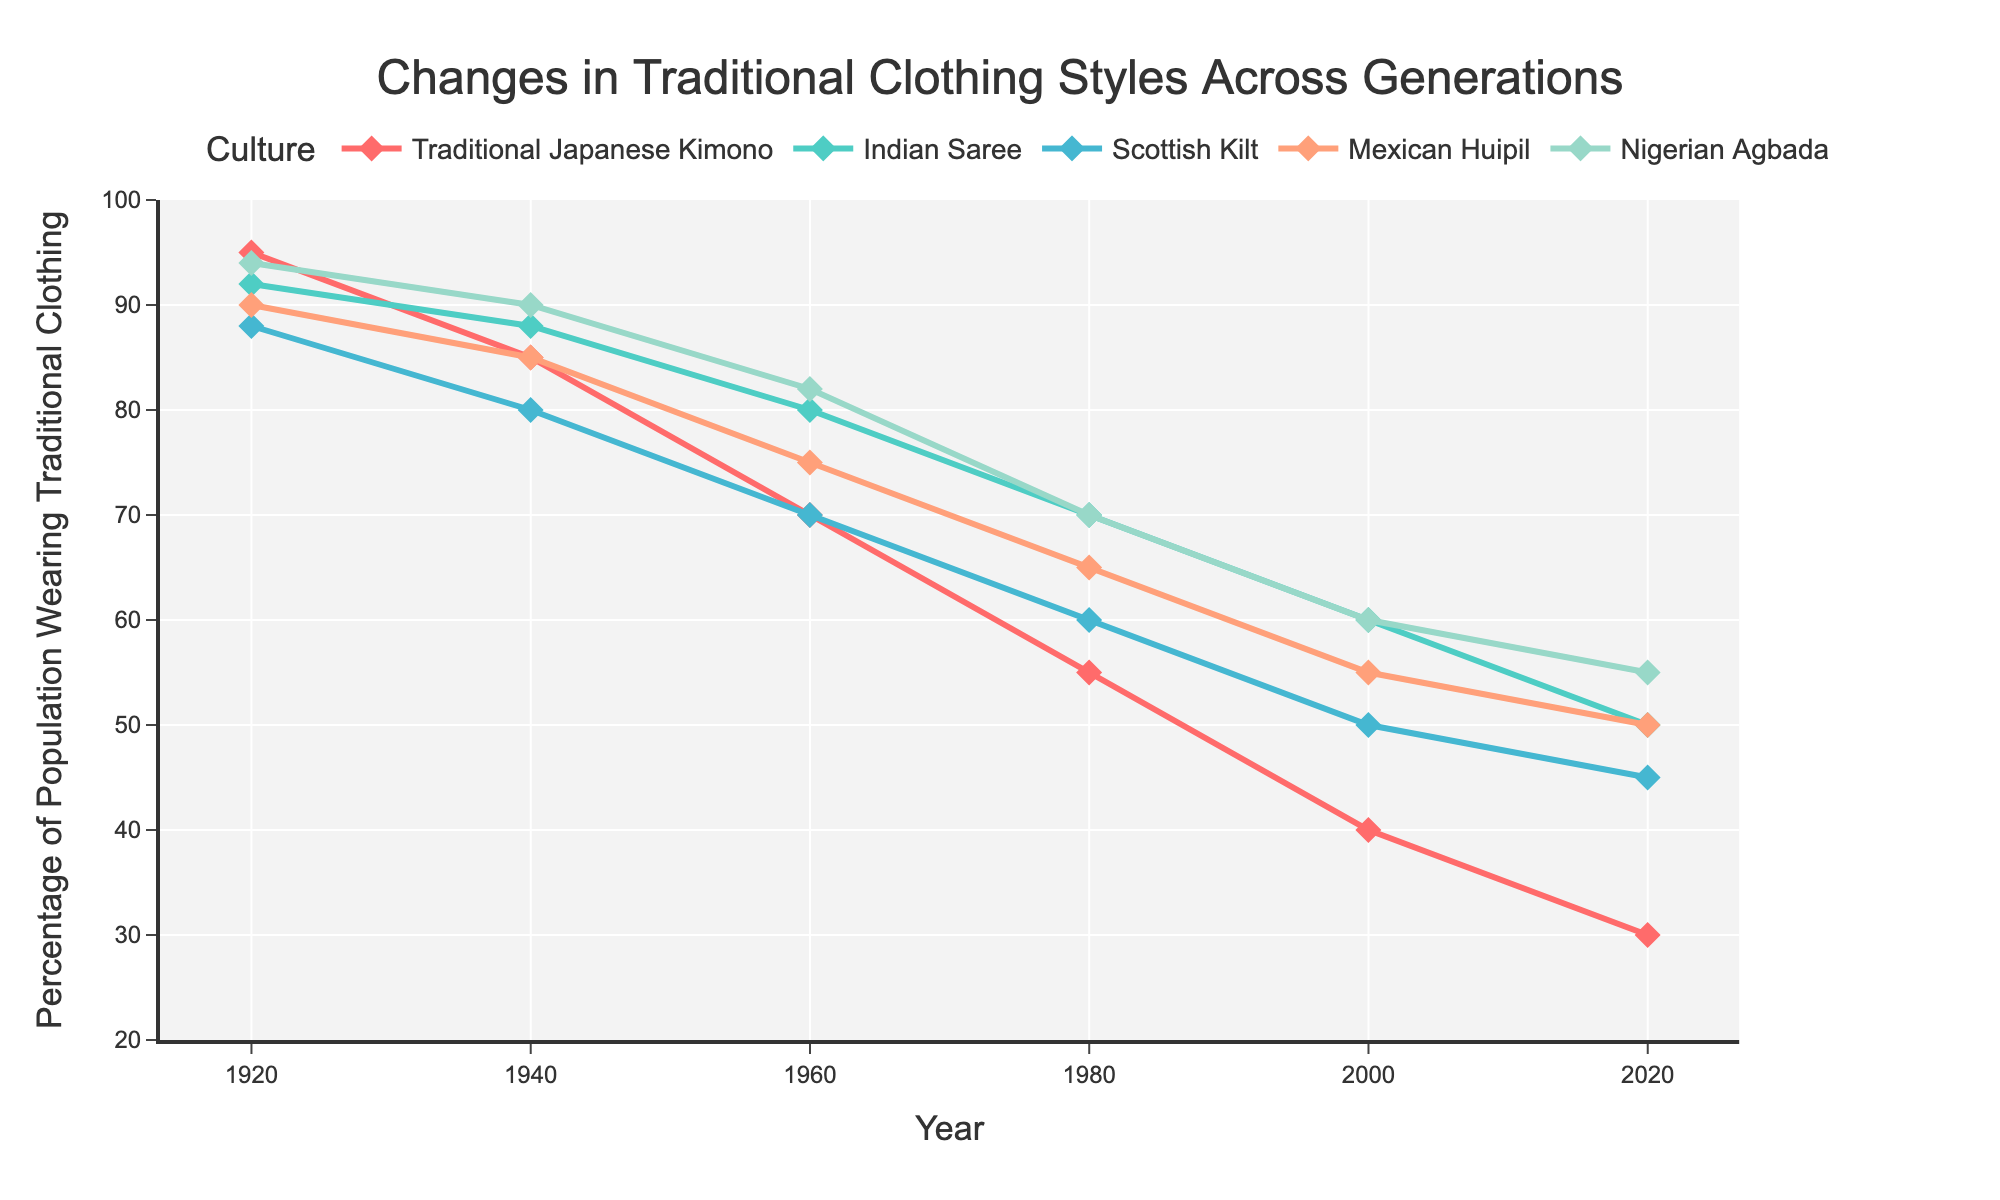What trend do you observe in the percentage of the population wearing the Traditional Japanese Kimono from 1920 to 2020? The percentage of the population wearing the Traditional Japanese Kimono has decreased steadily from 95% in 1920 to 30% in 2020. This shows a significant decline over the decades.
Answer: A significant decline Which traditional clothing showed the least decrease in percentage between 1920 and 2020? To find the least decrease, we need to calculate the difference for each item. Traditional Japanese Kimono: 95 - 30 = 65, Indian Saree: 92 - 50 = 42, Scottish Kilt: 88 - 45 = 43, Mexican Huipil: 90 - 50 = 40, Nigerian Agbada: 94 - 55 = 39. The Nigerian Agbada showed the least decrease.
Answer: Nigerian Agbada In which year did the percentage of the population wearing the Indian Saree first drop below 70%? By looking at the Indian Saree curve, the first year it drops below 70% is 1980.
Answer: 1980 Compare the trend of the percentage of populations wearing the Scottish Kilt and the Mexican Huipil from 1920 to 2020. Which one had a steeper decline? To determine the steeper decline, calculate the rate of decline for each. Scottish Kilt: (88 - 45) / (2020 - 1920) = 43/100 = 0.43 per year. Mexican Huipil: (90 - 50) / 100 = 40/100 = 0.4 per year. The Scottish Kilt had a steeper decline.
Answer: Scottish Kilt What is the average percentage of the population wearing the Nigerian Agbada over the recorded years? Sum the percentages from 1920, 1940, 1960, 1980, 2000, and 2020 and divide by the number of years. (94+90+82+70+60+55)/6 = 75.17.
Answer: 75.17% Between the Indian Saree and Traditional Japanese Kimono, which had a higher percentage of the population wearing it in 2000? From the chart, the Indian Saree has 60% in 2000, while the Traditional Japanese Kimono has 40%.
Answer: Indian Saree In what year did the percentage of the population wearing the Mexican Huipil equal that of the Traditional Japanese Kimono? Observing the curves, the percentages equal around the year 2000. Both are at approximately 40-50% in 2000.
Answer: 2000 How does the percentage of the population wearing traditional clothing in 2020 compare between the Mexican Huipil and the Nigerian Agbada? In 2020, the percentage for the Mexican Huipil is 50% while for the Nigerian Agbada it is 55%. The Nigerian Agbada has a higher percentage.
Answer: Nigerian Agbada is higher If the trends continue, which traditional clothing is likely to be worn by the smallest percentage of the population in 2040? Extrapolating the trends from the chart, the Traditional Japanese Kimono, which has been consistently decreasing and is the lowest in 2020, is likely to be the smallest in 2040.
Answer: Traditional Japanese Kimono 